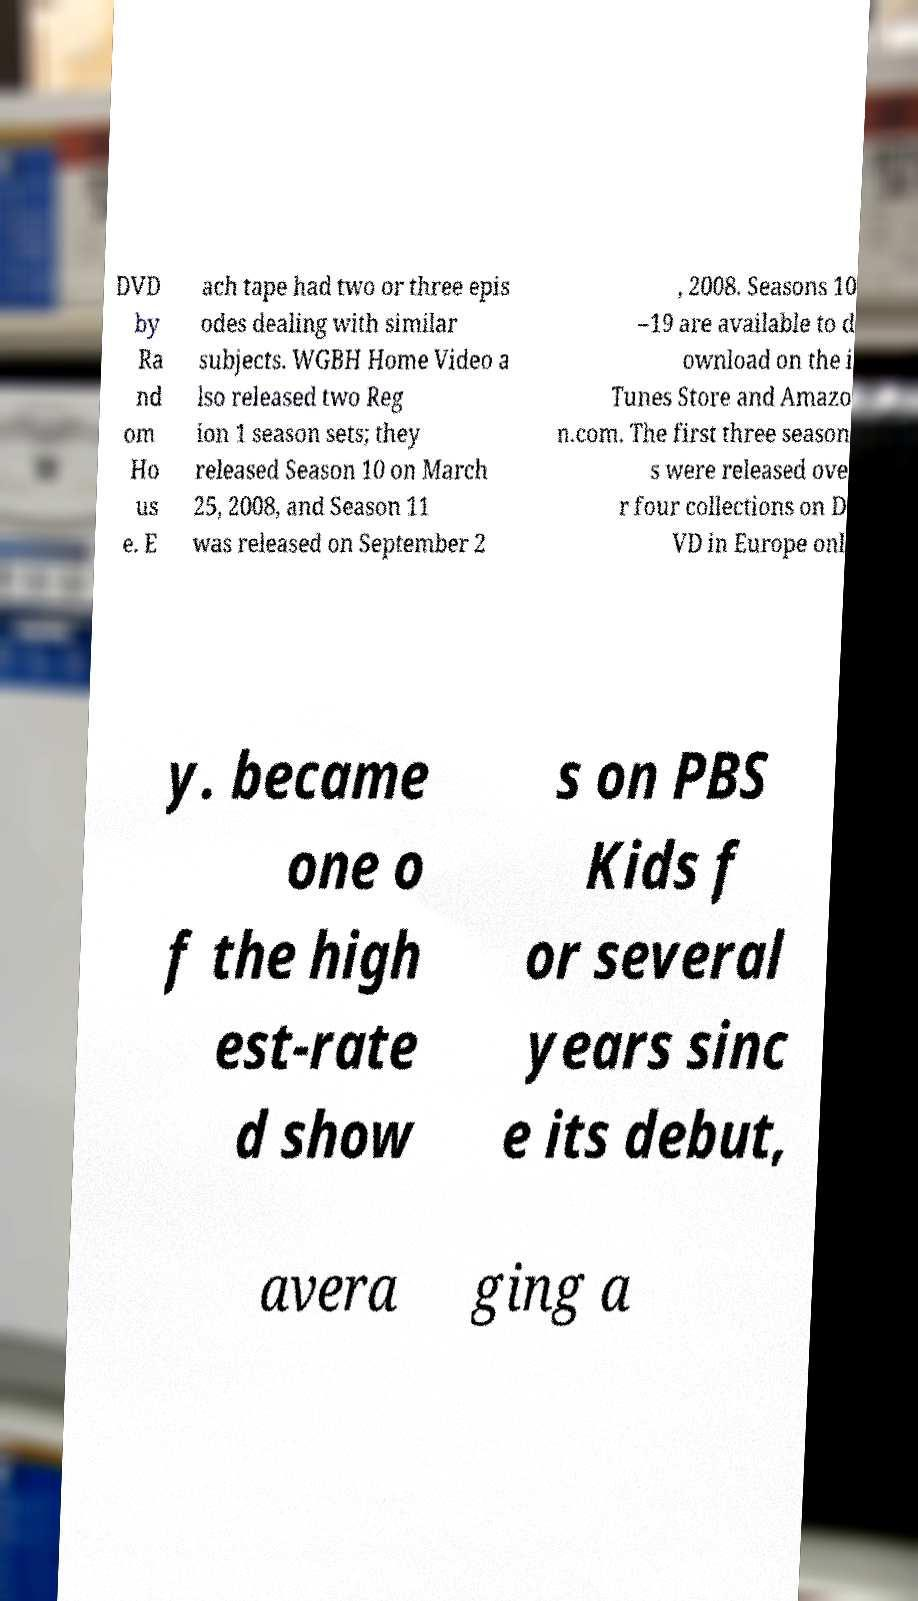Could you assist in decoding the text presented in this image and type it out clearly? DVD by Ra nd om Ho us e. E ach tape had two or three epis odes dealing with similar subjects. WGBH Home Video a lso released two Reg ion 1 season sets; they released Season 10 on March 25, 2008, and Season 11 was released on September 2 , 2008. Seasons 10 –19 are available to d ownload on the i Tunes Store and Amazo n.com. The first three season s were released ove r four collections on D VD in Europe onl y. became one o f the high est-rate d show s on PBS Kids f or several years sinc e its debut, avera ging a 